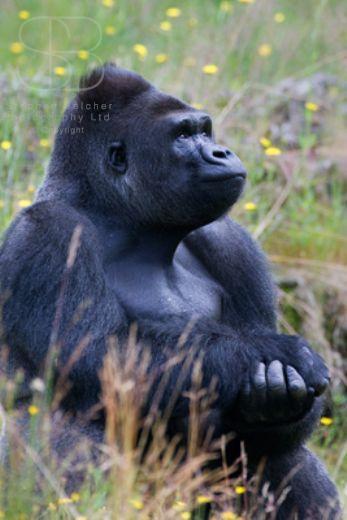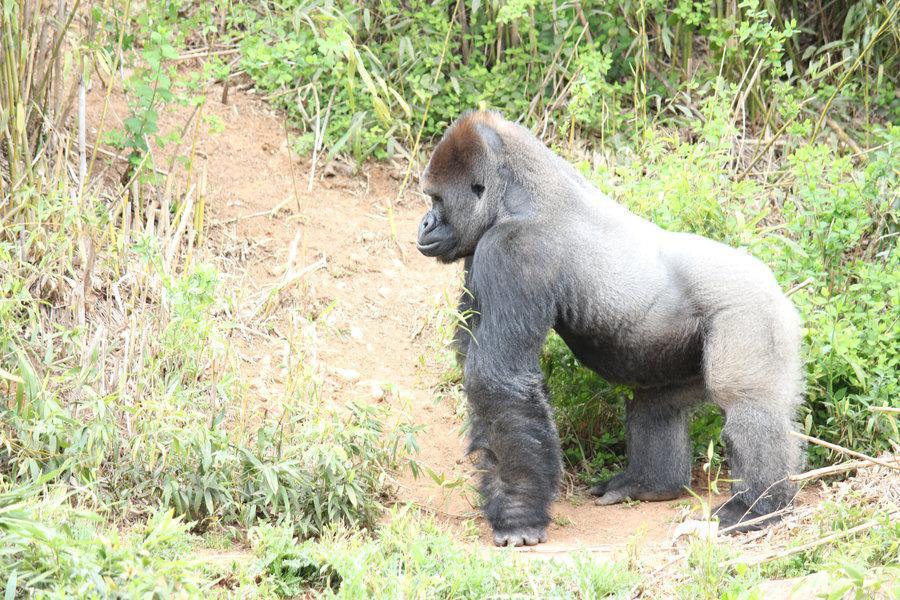The first image is the image on the left, the second image is the image on the right. For the images shown, is this caption "The left image contains a gorilla sitting down and looking towards the right." true? Answer yes or no. Yes. 